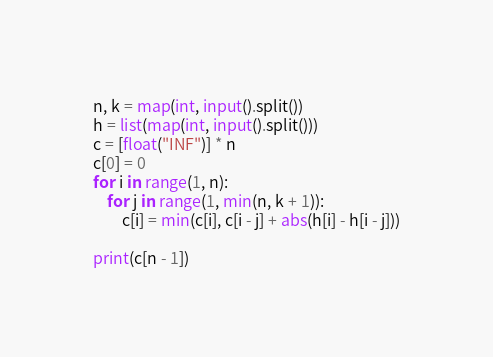Convert code to text. <code><loc_0><loc_0><loc_500><loc_500><_Python_>n, k = map(int, input().split())
h = list(map(int, input().split()))
c = [float("INF")] * n
c[0] = 0
for i in range(1, n):
    for j in range(1, min(n, k + 1)):
        c[i] = min(c[i], c[i - j] + abs(h[i] - h[i - j]))

print(c[n - 1])

</code> 